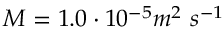<formula> <loc_0><loc_0><loc_500><loc_500>M = 1 . 0 \cdot 1 0 ^ { - 5 } m ^ { 2 } \ s ^ { - 1 }</formula> 